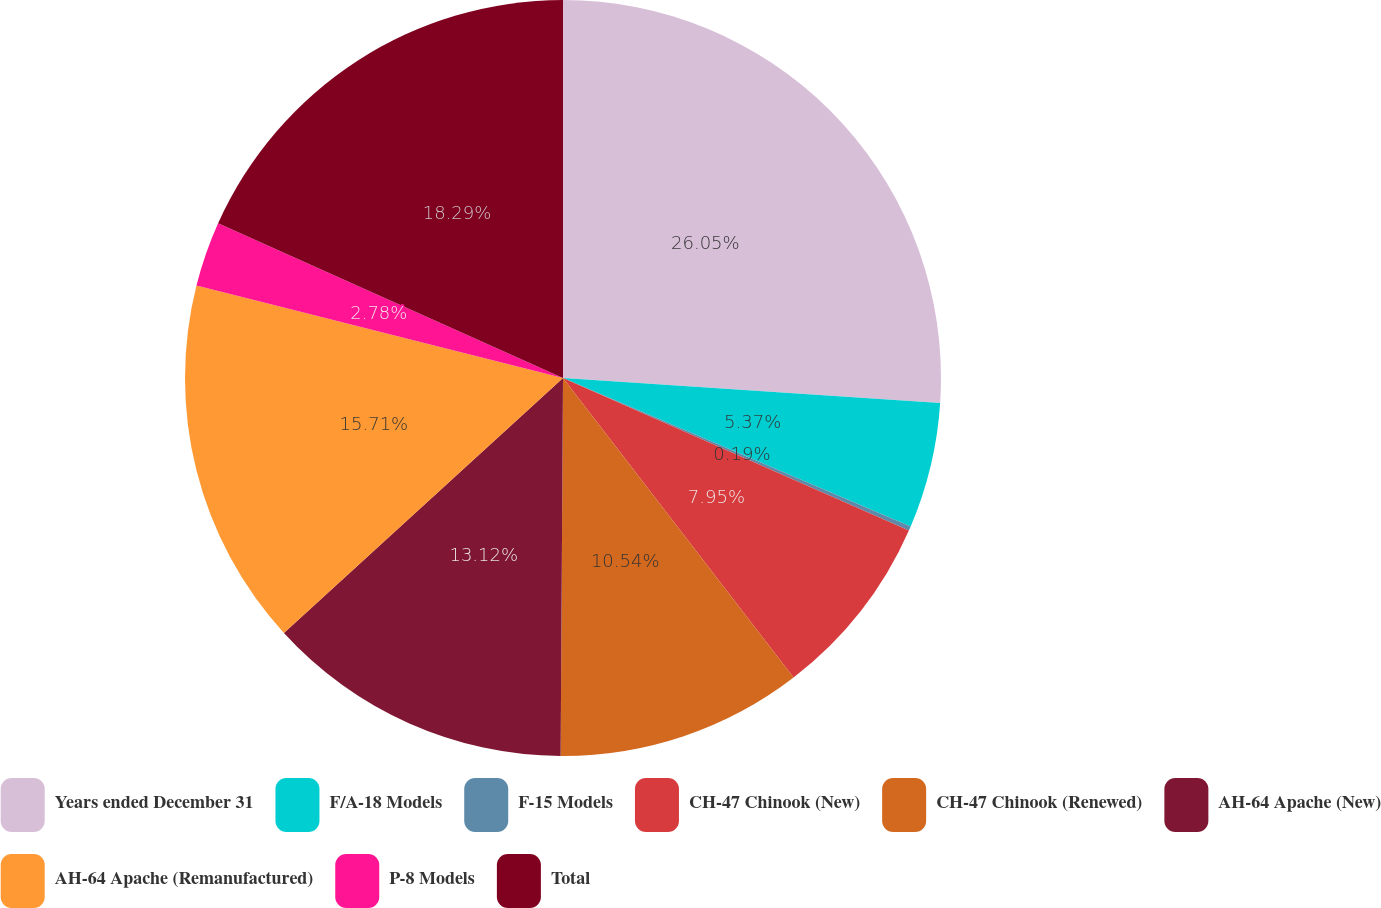<chart> <loc_0><loc_0><loc_500><loc_500><pie_chart><fcel>Years ended December 31<fcel>F/A-18 Models<fcel>F-15 Models<fcel>CH-47 Chinook (New)<fcel>CH-47 Chinook (Renewed)<fcel>AH-64 Apache (New)<fcel>AH-64 Apache (Remanufactured)<fcel>P-8 Models<fcel>Total<nl><fcel>26.05%<fcel>5.37%<fcel>0.19%<fcel>7.95%<fcel>10.54%<fcel>13.12%<fcel>15.71%<fcel>2.78%<fcel>18.29%<nl></chart> 